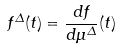<formula> <loc_0><loc_0><loc_500><loc_500>f ^ { \Delta } ( t ) = \frac { d f } { d \mu ^ { \Delta } } ( t )</formula> 